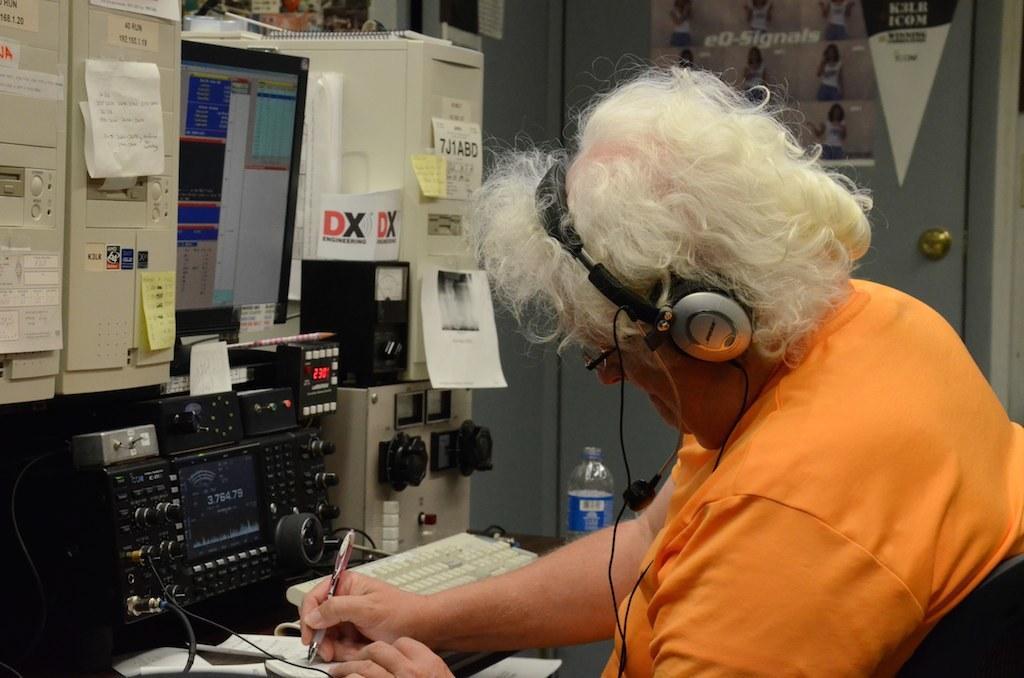Please provide a concise description of this image. In this picture I can see a women in front and I see that she is holding a pen and I can also see that she is wearing orange color top. In front of her I can see a monitor, a keyboard and few other equipment and I can also see papers, on which there is something written. In the background I can see few pictures of women and I see something is written. 